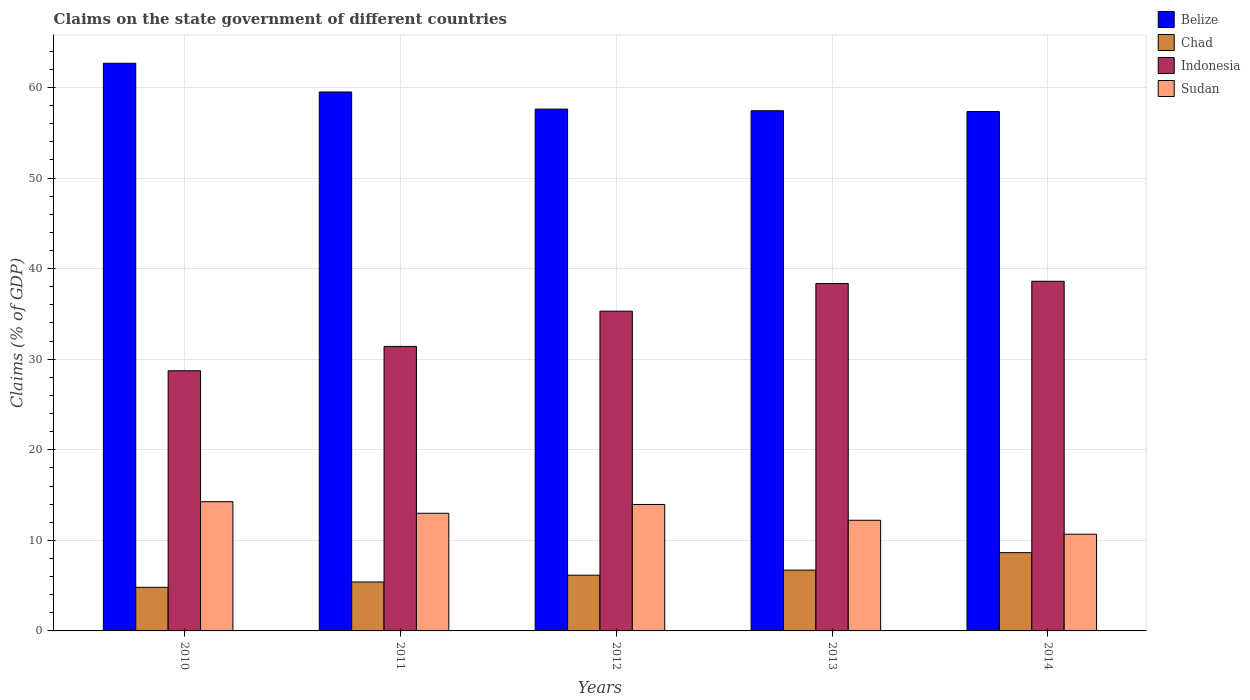Are the number of bars on each tick of the X-axis equal?
Your answer should be very brief. Yes. What is the label of the 2nd group of bars from the left?
Your response must be concise. 2011. In how many cases, is the number of bars for a given year not equal to the number of legend labels?
Offer a terse response. 0. What is the percentage of GDP claimed on the state government in Sudan in 2011?
Make the answer very short. 12.99. Across all years, what is the maximum percentage of GDP claimed on the state government in Chad?
Provide a short and direct response. 8.64. Across all years, what is the minimum percentage of GDP claimed on the state government in Chad?
Keep it short and to the point. 4.81. In which year was the percentage of GDP claimed on the state government in Chad maximum?
Offer a terse response. 2014. In which year was the percentage of GDP claimed on the state government in Sudan minimum?
Make the answer very short. 2014. What is the total percentage of GDP claimed on the state government in Chad in the graph?
Your response must be concise. 31.73. What is the difference between the percentage of GDP claimed on the state government in Sudan in 2011 and that in 2012?
Your answer should be very brief. -0.97. What is the difference between the percentage of GDP claimed on the state government in Belize in 2014 and the percentage of GDP claimed on the state government in Sudan in 2012?
Ensure brevity in your answer.  43.39. What is the average percentage of GDP claimed on the state government in Chad per year?
Keep it short and to the point. 6.35. In the year 2012, what is the difference between the percentage of GDP claimed on the state government in Indonesia and percentage of GDP claimed on the state government in Belize?
Provide a short and direct response. -22.31. In how many years, is the percentage of GDP claimed on the state government in Chad greater than 8 %?
Give a very brief answer. 1. What is the ratio of the percentage of GDP claimed on the state government in Chad in 2011 to that in 2014?
Ensure brevity in your answer.  0.63. What is the difference between the highest and the second highest percentage of GDP claimed on the state government in Chad?
Provide a short and direct response. 1.93. What is the difference between the highest and the lowest percentage of GDP claimed on the state government in Sudan?
Your answer should be very brief. 3.59. In how many years, is the percentage of GDP claimed on the state government in Indonesia greater than the average percentage of GDP claimed on the state government in Indonesia taken over all years?
Offer a very short reply. 3. What does the 3rd bar from the right in 2013 represents?
Keep it short and to the point. Chad. Are the values on the major ticks of Y-axis written in scientific E-notation?
Ensure brevity in your answer.  No. Does the graph contain any zero values?
Ensure brevity in your answer.  No. Does the graph contain grids?
Offer a terse response. Yes. Where does the legend appear in the graph?
Offer a very short reply. Top right. How many legend labels are there?
Your answer should be very brief. 4. How are the legend labels stacked?
Provide a short and direct response. Vertical. What is the title of the graph?
Offer a terse response. Claims on the state government of different countries. What is the label or title of the Y-axis?
Your response must be concise. Claims (% of GDP). What is the Claims (% of GDP) of Belize in 2010?
Your response must be concise. 62.67. What is the Claims (% of GDP) of Chad in 2010?
Provide a short and direct response. 4.81. What is the Claims (% of GDP) of Indonesia in 2010?
Ensure brevity in your answer.  28.72. What is the Claims (% of GDP) in Sudan in 2010?
Keep it short and to the point. 14.27. What is the Claims (% of GDP) of Belize in 2011?
Make the answer very short. 59.5. What is the Claims (% of GDP) in Chad in 2011?
Ensure brevity in your answer.  5.4. What is the Claims (% of GDP) in Indonesia in 2011?
Give a very brief answer. 31.41. What is the Claims (% of GDP) of Sudan in 2011?
Provide a short and direct response. 12.99. What is the Claims (% of GDP) of Belize in 2012?
Provide a short and direct response. 57.61. What is the Claims (% of GDP) of Chad in 2012?
Give a very brief answer. 6.15. What is the Claims (% of GDP) in Indonesia in 2012?
Give a very brief answer. 35.3. What is the Claims (% of GDP) in Sudan in 2012?
Keep it short and to the point. 13.96. What is the Claims (% of GDP) in Belize in 2013?
Your response must be concise. 57.44. What is the Claims (% of GDP) of Chad in 2013?
Make the answer very short. 6.72. What is the Claims (% of GDP) of Indonesia in 2013?
Offer a very short reply. 38.35. What is the Claims (% of GDP) of Sudan in 2013?
Your answer should be very brief. 12.22. What is the Claims (% of GDP) in Belize in 2014?
Keep it short and to the point. 57.35. What is the Claims (% of GDP) of Chad in 2014?
Your answer should be compact. 8.64. What is the Claims (% of GDP) of Indonesia in 2014?
Keep it short and to the point. 38.61. What is the Claims (% of GDP) of Sudan in 2014?
Your answer should be compact. 10.68. Across all years, what is the maximum Claims (% of GDP) in Belize?
Keep it short and to the point. 62.67. Across all years, what is the maximum Claims (% of GDP) in Chad?
Offer a terse response. 8.64. Across all years, what is the maximum Claims (% of GDP) of Indonesia?
Your answer should be compact. 38.61. Across all years, what is the maximum Claims (% of GDP) of Sudan?
Offer a very short reply. 14.27. Across all years, what is the minimum Claims (% of GDP) of Belize?
Your response must be concise. 57.35. Across all years, what is the minimum Claims (% of GDP) of Chad?
Keep it short and to the point. 4.81. Across all years, what is the minimum Claims (% of GDP) of Indonesia?
Your response must be concise. 28.72. Across all years, what is the minimum Claims (% of GDP) in Sudan?
Give a very brief answer. 10.68. What is the total Claims (% of GDP) of Belize in the graph?
Ensure brevity in your answer.  294.57. What is the total Claims (% of GDP) of Chad in the graph?
Provide a short and direct response. 31.73. What is the total Claims (% of GDP) of Indonesia in the graph?
Your answer should be compact. 172.4. What is the total Claims (% of GDP) of Sudan in the graph?
Keep it short and to the point. 64.11. What is the difference between the Claims (% of GDP) of Belize in 2010 and that in 2011?
Your answer should be very brief. 3.17. What is the difference between the Claims (% of GDP) of Chad in 2010 and that in 2011?
Provide a short and direct response. -0.59. What is the difference between the Claims (% of GDP) of Indonesia in 2010 and that in 2011?
Make the answer very short. -2.69. What is the difference between the Claims (% of GDP) in Sudan in 2010 and that in 2011?
Provide a short and direct response. 1.28. What is the difference between the Claims (% of GDP) in Belize in 2010 and that in 2012?
Offer a very short reply. 5.06. What is the difference between the Claims (% of GDP) of Chad in 2010 and that in 2012?
Your answer should be compact. -1.34. What is the difference between the Claims (% of GDP) in Indonesia in 2010 and that in 2012?
Your answer should be very brief. -6.58. What is the difference between the Claims (% of GDP) of Sudan in 2010 and that in 2012?
Keep it short and to the point. 0.31. What is the difference between the Claims (% of GDP) of Belize in 2010 and that in 2013?
Offer a very short reply. 5.24. What is the difference between the Claims (% of GDP) of Chad in 2010 and that in 2013?
Give a very brief answer. -1.9. What is the difference between the Claims (% of GDP) of Indonesia in 2010 and that in 2013?
Ensure brevity in your answer.  -9.63. What is the difference between the Claims (% of GDP) in Sudan in 2010 and that in 2013?
Offer a terse response. 2.05. What is the difference between the Claims (% of GDP) of Belize in 2010 and that in 2014?
Offer a very short reply. 5.33. What is the difference between the Claims (% of GDP) in Chad in 2010 and that in 2014?
Provide a short and direct response. -3.83. What is the difference between the Claims (% of GDP) of Indonesia in 2010 and that in 2014?
Provide a succinct answer. -9.88. What is the difference between the Claims (% of GDP) in Sudan in 2010 and that in 2014?
Your answer should be very brief. 3.59. What is the difference between the Claims (% of GDP) in Belize in 2011 and that in 2012?
Keep it short and to the point. 1.89. What is the difference between the Claims (% of GDP) in Chad in 2011 and that in 2012?
Provide a short and direct response. -0.75. What is the difference between the Claims (% of GDP) of Indonesia in 2011 and that in 2012?
Offer a very short reply. -3.89. What is the difference between the Claims (% of GDP) of Sudan in 2011 and that in 2012?
Your answer should be compact. -0.97. What is the difference between the Claims (% of GDP) of Belize in 2011 and that in 2013?
Your response must be concise. 2.07. What is the difference between the Claims (% of GDP) of Chad in 2011 and that in 2013?
Offer a very short reply. -1.31. What is the difference between the Claims (% of GDP) in Indonesia in 2011 and that in 2013?
Your answer should be very brief. -6.94. What is the difference between the Claims (% of GDP) in Sudan in 2011 and that in 2013?
Offer a very short reply. 0.77. What is the difference between the Claims (% of GDP) of Belize in 2011 and that in 2014?
Your answer should be very brief. 2.16. What is the difference between the Claims (% of GDP) in Chad in 2011 and that in 2014?
Provide a succinct answer. -3.24. What is the difference between the Claims (% of GDP) of Indonesia in 2011 and that in 2014?
Offer a very short reply. -7.2. What is the difference between the Claims (% of GDP) of Sudan in 2011 and that in 2014?
Ensure brevity in your answer.  2.31. What is the difference between the Claims (% of GDP) of Belize in 2012 and that in 2013?
Provide a succinct answer. 0.18. What is the difference between the Claims (% of GDP) of Chad in 2012 and that in 2013?
Offer a very short reply. -0.56. What is the difference between the Claims (% of GDP) of Indonesia in 2012 and that in 2013?
Ensure brevity in your answer.  -3.05. What is the difference between the Claims (% of GDP) in Sudan in 2012 and that in 2013?
Offer a terse response. 1.74. What is the difference between the Claims (% of GDP) of Belize in 2012 and that in 2014?
Keep it short and to the point. 0.27. What is the difference between the Claims (% of GDP) of Chad in 2012 and that in 2014?
Offer a terse response. -2.49. What is the difference between the Claims (% of GDP) of Indonesia in 2012 and that in 2014?
Give a very brief answer. -3.3. What is the difference between the Claims (% of GDP) in Sudan in 2012 and that in 2014?
Your answer should be compact. 3.28. What is the difference between the Claims (% of GDP) in Belize in 2013 and that in 2014?
Make the answer very short. 0.09. What is the difference between the Claims (% of GDP) in Chad in 2013 and that in 2014?
Give a very brief answer. -1.93. What is the difference between the Claims (% of GDP) of Indonesia in 2013 and that in 2014?
Keep it short and to the point. -0.25. What is the difference between the Claims (% of GDP) of Sudan in 2013 and that in 2014?
Your answer should be compact. 1.54. What is the difference between the Claims (% of GDP) of Belize in 2010 and the Claims (% of GDP) of Chad in 2011?
Your answer should be compact. 57.27. What is the difference between the Claims (% of GDP) of Belize in 2010 and the Claims (% of GDP) of Indonesia in 2011?
Your answer should be very brief. 31.26. What is the difference between the Claims (% of GDP) of Belize in 2010 and the Claims (% of GDP) of Sudan in 2011?
Offer a terse response. 49.68. What is the difference between the Claims (% of GDP) in Chad in 2010 and the Claims (% of GDP) in Indonesia in 2011?
Make the answer very short. -26.6. What is the difference between the Claims (% of GDP) of Chad in 2010 and the Claims (% of GDP) of Sudan in 2011?
Offer a terse response. -8.18. What is the difference between the Claims (% of GDP) in Indonesia in 2010 and the Claims (% of GDP) in Sudan in 2011?
Make the answer very short. 15.73. What is the difference between the Claims (% of GDP) in Belize in 2010 and the Claims (% of GDP) in Chad in 2012?
Give a very brief answer. 56.52. What is the difference between the Claims (% of GDP) of Belize in 2010 and the Claims (% of GDP) of Indonesia in 2012?
Provide a succinct answer. 27.37. What is the difference between the Claims (% of GDP) in Belize in 2010 and the Claims (% of GDP) in Sudan in 2012?
Ensure brevity in your answer.  48.71. What is the difference between the Claims (% of GDP) in Chad in 2010 and the Claims (% of GDP) in Indonesia in 2012?
Offer a terse response. -30.49. What is the difference between the Claims (% of GDP) in Chad in 2010 and the Claims (% of GDP) in Sudan in 2012?
Your answer should be compact. -9.15. What is the difference between the Claims (% of GDP) in Indonesia in 2010 and the Claims (% of GDP) in Sudan in 2012?
Offer a terse response. 14.76. What is the difference between the Claims (% of GDP) in Belize in 2010 and the Claims (% of GDP) in Chad in 2013?
Keep it short and to the point. 55.96. What is the difference between the Claims (% of GDP) of Belize in 2010 and the Claims (% of GDP) of Indonesia in 2013?
Offer a terse response. 24.32. What is the difference between the Claims (% of GDP) of Belize in 2010 and the Claims (% of GDP) of Sudan in 2013?
Your answer should be very brief. 50.46. What is the difference between the Claims (% of GDP) of Chad in 2010 and the Claims (% of GDP) of Indonesia in 2013?
Keep it short and to the point. -33.54. What is the difference between the Claims (% of GDP) of Chad in 2010 and the Claims (% of GDP) of Sudan in 2013?
Keep it short and to the point. -7.4. What is the difference between the Claims (% of GDP) in Indonesia in 2010 and the Claims (% of GDP) in Sudan in 2013?
Provide a short and direct response. 16.51. What is the difference between the Claims (% of GDP) in Belize in 2010 and the Claims (% of GDP) in Chad in 2014?
Provide a short and direct response. 54.03. What is the difference between the Claims (% of GDP) of Belize in 2010 and the Claims (% of GDP) of Indonesia in 2014?
Provide a succinct answer. 24.07. What is the difference between the Claims (% of GDP) in Belize in 2010 and the Claims (% of GDP) in Sudan in 2014?
Provide a succinct answer. 52. What is the difference between the Claims (% of GDP) of Chad in 2010 and the Claims (% of GDP) of Indonesia in 2014?
Offer a terse response. -33.79. What is the difference between the Claims (% of GDP) in Chad in 2010 and the Claims (% of GDP) in Sudan in 2014?
Provide a short and direct response. -5.86. What is the difference between the Claims (% of GDP) of Indonesia in 2010 and the Claims (% of GDP) of Sudan in 2014?
Make the answer very short. 18.05. What is the difference between the Claims (% of GDP) of Belize in 2011 and the Claims (% of GDP) of Chad in 2012?
Your answer should be compact. 53.35. What is the difference between the Claims (% of GDP) of Belize in 2011 and the Claims (% of GDP) of Indonesia in 2012?
Your answer should be compact. 24.2. What is the difference between the Claims (% of GDP) of Belize in 2011 and the Claims (% of GDP) of Sudan in 2012?
Your answer should be very brief. 45.54. What is the difference between the Claims (% of GDP) of Chad in 2011 and the Claims (% of GDP) of Indonesia in 2012?
Your response must be concise. -29.9. What is the difference between the Claims (% of GDP) in Chad in 2011 and the Claims (% of GDP) in Sudan in 2012?
Provide a short and direct response. -8.56. What is the difference between the Claims (% of GDP) in Indonesia in 2011 and the Claims (% of GDP) in Sudan in 2012?
Keep it short and to the point. 17.45. What is the difference between the Claims (% of GDP) of Belize in 2011 and the Claims (% of GDP) of Chad in 2013?
Keep it short and to the point. 52.79. What is the difference between the Claims (% of GDP) in Belize in 2011 and the Claims (% of GDP) in Indonesia in 2013?
Ensure brevity in your answer.  21.15. What is the difference between the Claims (% of GDP) of Belize in 2011 and the Claims (% of GDP) of Sudan in 2013?
Offer a very short reply. 47.29. What is the difference between the Claims (% of GDP) of Chad in 2011 and the Claims (% of GDP) of Indonesia in 2013?
Your answer should be very brief. -32.95. What is the difference between the Claims (% of GDP) in Chad in 2011 and the Claims (% of GDP) in Sudan in 2013?
Provide a short and direct response. -6.81. What is the difference between the Claims (% of GDP) in Indonesia in 2011 and the Claims (% of GDP) in Sudan in 2013?
Give a very brief answer. 19.19. What is the difference between the Claims (% of GDP) in Belize in 2011 and the Claims (% of GDP) in Chad in 2014?
Keep it short and to the point. 50.86. What is the difference between the Claims (% of GDP) in Belize in 2011 and the Claims (% of GDP) in Indonesia in 2014?
Your answer should be compact. 20.9. What is the difference between the Claims (% of GDP) in Belize in 2011 and the Claims (% of GDP) in Sudan in 2014?
Your answer should be compact. 48.83. What is the difference between the Claims (% of GDP) of Chad in 2011 and the Claims (% of GDP) of Indonesia in 2014?
Make the answer very short. -33.2. What is the difference between the Claims (% of GDP) of Chad in 2011 and the Claims (% of GDP) of Sudan in 2014?
Ensure brevity in your answer.  -5.27. What is the difference between the Claims (% of GDP) of Indonesia in 2011 and the Claims (% of GDP) of Sudan in 2014?
Your response must be concise. 20.73. What is the difference between the Claims (% of GDP) of Belize in 2012 and the Claims (% of GDP) of Chad in 2013?
Offer a very short reply. 50.9. What is the difference between the Claims (% of GDP) in Belize in 2012 and the Claims (% of GDP) in Indonesia in 2013?
Give a very brief answer. 19.26. What is the difference between the Claims (% of GDP) in Belize in 2012 and the Claims (% of GDP) in Sudan in 2013?
Make the answer very short. 45.39. What is the difference between the Claims (% of GDP) in Chad in 2012 and the Claims (% of GDP) in Indonesia in 2013?
Your answer should be very brief. -32.2. What is the difference between the Claims (% of GDP) in Chad in 2012 and the Claims (% of GDP) in Sudan in 2013?
Provide a short and direct response. -6.07. What is the difference between the Claims (% of GDP) in Indonesia in 2012 and the Claims (% of GDP) in Sudan in 2013?
Ensure brevity in your answer.  23.09. What is the difference between the Claims (% of GDP) of Belize in 2012 and the Claims (% of GDP) of Chad in 2014?
Offer a very short reply. 48.97. What is the difference between the Claims (% of GDP) in Belize in 2012 and the Claims (% of GDP) in Indonesia in 2014?
Offer a very short reply. 19.01. What is the difference between the Claims (% of GDP) in Belize in 2012 and the Claims (% of GDP) in Sudan in 2014?
Your answer should be very brief. 46.93. What is the difference between the Claims (% of GDP) in Chad in 2012 and the Claims (% of GDP) in Indonesia in 2014?
Ensure brevity in your answer.  -32.45. What is the difference between the Claims (% of GDP) of Chad in 2012 and the Claims (% of GDP) of Sudan in 2014?
Ensure brevity in your answer.  -4.53. What is the difference between the Claims (% of GDP) in Indonesia in 2012 and the Claims (% of GDP) in Sudan in 2014?
Offer a very short reply. 24.63. What is the difference between the Claims (% of GDP) in Belize in 2013 and the Claims (% of GDP) in Chad in 2014?
Your response must be concise. 48.79. What is the difference between the Claims (% of GDP) of Belize in 2013 and the Claims (% of GDP) of Indonesia in 2014?
Offer a terse response. 18.83. What is the difference between the Claims (% of GDP) in Belize in 2013 and the Claims (% of GDP) in Sudan in 2014?
Provide a short and direct response. 46.76. What is the difference between the Claims (% of GDP) of Chad in 2013 and the Claims (% of GDP) of Indonesia in 2014?
Give a very brief answer. -31.89. What is the difference between the Claims (% of GDP) in Chad in 2013 and the Claims (% of GDP) in Sudan in 2014?
Your response must be concise. -3.96. What is the difference between the Claims (% of GDP) of Indonesia in 2013 and the Claims (% of GDP) of Sudan in 2014?
Your response must be concise. 27.68. What is the average Claims (% of GDP) in Belize per year?
Your answer should be very brief. 58.91. What is the average Claims (% of GDP) in Chad per year?
Your answer should be very brief. 6.35. What is the average Claims (% of GDP) in Indonesia per year?
Keep it short and to the point. 34.48. What is the average Claims (% of GDP) in Sudan per year?
Offer a terse response. 12.82. In the year 2010, what is the difference between the Claims (% of GDP) in Belize and Claims (% of GDP) in Chad?
Provide a short and direct response. 57.86. In the year 2010, what is the difference between the Claims (% of GDP) of Belize and Claims (% of GDP) of Indonesia?
Your answer should be compact. 33.95. In the year 2010, what is the difference between the Claims (% of GDP) of Belize and Claims (% of GDP) of Sudan?
Give a very brief answer. 48.41. In the year 2010, what is the difference between the Claims (% of GDP) of Chad and Claims (% of GDP) of Indonesia?
Offer a terse response. -23.91. In the year 2010, what is the difference between the Claims (% of GDP) of Chad and Claims (% of GDP) of Sudan?
Provide a short and direct response. -9.45. In the year 2010, what is the difference between the Claims (% of GDP) of Indonesia and Claims (% of GDP) of Sudan?
Your response must be concise. 14.46. In the year 2011, what is the difference between the Claims (% of GDP) in Belize and Claims (% of GDP) in Chad?
Offer a terse response. 54.1. In the year 2011, what is the difference between the Claims (% of GDP) in Belize and Claims (% of GDP) in Indonesia?
Provide a short and direct response. 28.09. In the year 2011, what is the difference between the Claims (% of GDP) in Belize and Claims (% of GDP) in Sudan?
Provide a succinct answer. 46.51. In the year 2011, what is the difference between the Claims (% of GDP) in Chad and Claims (% of GDP) in Indonesia?
Your answer should be compact. -26.01. In the year 2011, what is the difference between the Claims (% of GDP) in Chad and Claims (% of GDP) in Sudan?
Provide a short and direct response. -7.59. In the year 2011, what is the difference between the Claims (% of GDP) of Indonesia and Claims (% of GDP) of Sudan?
Offer a terse response. 18.42. In the year 2012, what is the difference between the Claims (% of GDP) of Belize and Claims (% of GDP) of Chad?
Give a very brief answer. 51.46. In the year 2012, what is the difference between the Claims (% of GDP) of Belize and Claims (% of GDP) of Indonesia?
Offer a terse response. 22.31. In the year 2012, what is the difference between the Claims (% of GDP) in Belize and Claims (% of GDP) in Sudan?
Your answer should be very brief. 43.65. In the year 2012, what is the difference between the Claims (% of GDP) in Chad and Claims (% of GDP) in Indonesia?
Offer a terse response. -29.15. In the year 2012, what is the difference between the Claims (% of GDP) in Chad and Claims (% of GDP) in Sudan?
Provide a succinct answer. -7.81. In the year 2012, what is the difference between the Claims (% of GDP) in Indonesia and Claims (% of GDP) in Sudan?
Provide a succinct answer. 21.34. In the year 2013, what is the difference between the Claims (% of GDP) in Belize and Claims (% of GDP) in Chad?
Your answer should be very brief. 50.72. In the year 2013, what is the difference between the Claims (% of GDP) in Belize and Claims (% of GDP) in Indonesia?
Your answer should be compact. 19.08. In the year 2013, what is the difference between the Claims (% of GDP) in Belize and Claims (% of GDP) in Sudan?
Your response must be concise. 45.22. In the year 2013, what is the difference between the Claims (% of GDP) in Chad and Claims (% of GDP) in Indonesia?
Your answer should be compact. -31.64. In the year 2013, what is the difference between the Claims (% of GDP) in Chad and Claims (% of GDP) in Sudan?
Make the answer very short. -5.5. In the year 2013, what is the difference between the Claims (% of GDP) of Indonesia and Claims (% of GDP) of Sudan?
Make the answer very short. 26.14. In the year 2014, what is the difference between the Claims (% of GDP) of Belize and Claims (% of GDP) of Chad?
Your response must be concise. 48.7. In the year 2014, what is the difference between the Claims (% of GDP) of Belize and Claims (% of GDP) of Indonesia?
Your answer should be very brief. 18.74. In the year 2014, what is the difference between the Claims (% of GDP) of Belize and Claims (% of GDP) of Sudan?
Make the answer very short. 46.67. In the year 2014, what is the difference between the Claims (% of GDP) of Chad and Claims (% of GDP) of Indonesia?
Offer a terse response. -29.96. In the year 2014, what is the difference between the Claims (% of GDP) in Chad and Claims (% of GDP) in Sudan?
Keep it short and to the point. -2.04. In the year 2014, what is the difference between the Claims (% of GDP) of Indonesia and Claims (% of GDP) of Sudan?
Provide a succinct answer. 27.93. What is the ratio of the Claims (% of GDP) in Belize in 2010 to that in 2011?
Your answer should be very brief. 1.05. What is the ratio of the Claims (% of GDP) of Chad in 2010 to that in 2011?
Keep it short and to the point. 0.89. What is the ratio of the Claims (% of GDP) in Indonesia in 2010 to that in 2011?
Give a very brief answer. 0.91. What is the ratio of the Claims (% of GDP) of Sudan in 2010 to that in 2011?
Your answer should be compact. 1.1. What is the ratio of the Claims (% of GDP) of Belize in 2010 to that in 2012?
Provide a short and direct response. 1.09. What is the ratio of the Claims (% of GDP) of Chad in 2010 to that in 2012?
Keep it short and to the point. 0.78. What is the ratio of the Claims (% of GDP) of Indonesia in 2010 to that in 2012?
Keep it short and to the point. 0.81. What is the ratio of the Claims (% of GDP) in Sudan in 2010 to that in 2012?
Keep it short and to the point. 1.02. What is the ratio of the Claims (% of GDP) of Belize in 2010 to that in 2013?
Provide a succinct answer. 1.09. What is the ratio of the Claims (% of GDP) in Chad in 2010 to that in 2013?
Your answer should be very brief. 0.72. What is the ratio of the Claims (% of GDP) in Indonesia in 2010 to that in 2013?
Offer a terse response. 0.75. What is the ratio of the Claims (% of GDP) of Sudan in 2010 to that in 2013?
Your response must be concise. 1.17. What is the ratio of the Claims (% of GDP) in Belize in 2010 to that in 2014?
Offer a very short reply. 1.09. What is the ratio of the Claims (% of GDP) in Chad in 2010 to that in 2014?
Offer a terse response. 0.56. What is the ratio of the Claims (% of GDP) of Indonesia in 2010 to that in 2014?
Offer a terse response. 0.74. What is the ratio of the Claims (% of GDP) in Sudan in 2010 to that in 2014?
Your answer should be compact. 1.34. What is the ratio of the Claims (% of GDP) of Belize in 2011 to that in 2012?
Provide a succinct answer. 1.03. What is the ratio of the Claims (% of GDP) in Chad in 2011 to that in 2012?
Your answer should be compact. 0.88. What is the ratio of the Claims (% of GDP) in Indonesia in 2011 to that in 2012?
Keep it short and to the point. 0.89. What is the ratio of the Claims (% of GDP) of Sudan in 2011 to that in 2012?
Your response must be concise. 0.93. What is the ratio of the Claims (% of GDP) in Belize in 2011 to that in 2013?
Provide a succinct answer. 1.04. What is the ratio of the Claims (% of GDP) in Chad in 2011 to that in 2013?
Ensure brevity in your answer.  0.8. What is the ratio of the Claims (% of GDP) in Indonesia in 2011 to that in 2013?
Ensure brevity in your answer.  0.82. What is the ratio of the Claims (% of GDP) in Sudan in 2011 to that in 2013?
Ensure brevity in your answer.  1.06. What is the ratio of the Claims (% of GDP) in Belize in 2011 to that in 2014?
Keep it short and to the point. 1.04. What is the ratio of the Claims (% of GDP) of Chad in 2011 to that in 2014?
Your answer should be compact. 0.63. What is the ratio of the Claims (% of GDP) in Indonesia in 2011 to that in 2014?
Make the answer very short. 0.81. What is the ratio of the Claims (% of GDP) in Sudan in 2011 to that in 2014?
Your response must be concise. 1.22. What is the ratio of the Claims (% of GDP) in Belize in 2012 to that in 2013?
Offer a terse response. 1. What is the ratio of the Claims (% of GDP) in Chad in 2012 to that in 2013?
Your response must be concise. 0.92. What is the ratio of the Claims (% of GDP) in Indonesia in 2012 to that in 2013?
Your answer should be very brief. 0.92. What is the ratio of the Claims (% of GDP) of Sudan in 2012 to that in 2013?
Give a very brief answer. 1.14. What is the ratio of the Claims (% of GDP) of Chad in 2012 to that in 2014?
Offer a very short reply. 0.71. What is the ratio of the Claims (% of GDP) of Indonesia in 2012 to that in 2014?
Your answer should be very brief. 0.91. What is the ratio of the Claims (% of GDP) of Sudan in 2012 to that in 2014?
Ensure brevity in your answer.  1.31. What is the ratio of the Claims (% of GDP) in Belize in 2013 to that in 2014?
Your answer should be very brief. 1. What is the ratio of the Claims (% of GDP) of Chad in 2013 to that in 2014?
Your answer should be very brief. 0.78. What is the ratio of the Claims (% of GDP) in Indonesia in 2013 to that in 2014?
Your answer should be very brief. 0.99. What is the ratio of the Claims (% of GDP) of Sudan in 2013 to that in 2014?
Make the answer very short. 1.14. What is the difference between the highest and the second highest Claims (% of GDP) in Belize?
Offer a very short reply. 3.17. What is the difference between the highest and the second highest Claims (% of GDP) in Chad?
Your answer should be very brief. 1.93. What is the difference between the highest and the second highest Claims (% of GDP) of Indonesia?
Provide a succinct answer. 0.25. What is the difference between the highest and the second highest Claims (% of GDP) in Sudan?
Offer a terse response. 0.31. What is the difference between the highest and the lowest Claims (% of GDP) of Belize?
Offer a terse response. 5.33. What is the difference between the highest and the lowest Claims (% of GDP) of Chad?
Make the answer very short. 3.83. What is the difference between the highest and the lowest Claims (% of GDP) of Indonesia?
Offer a terse response. 9.88. What is the difference between the highest and the lowest Claims (% of GDP) of Sudan?
Your answer should be compact. 3.59. 